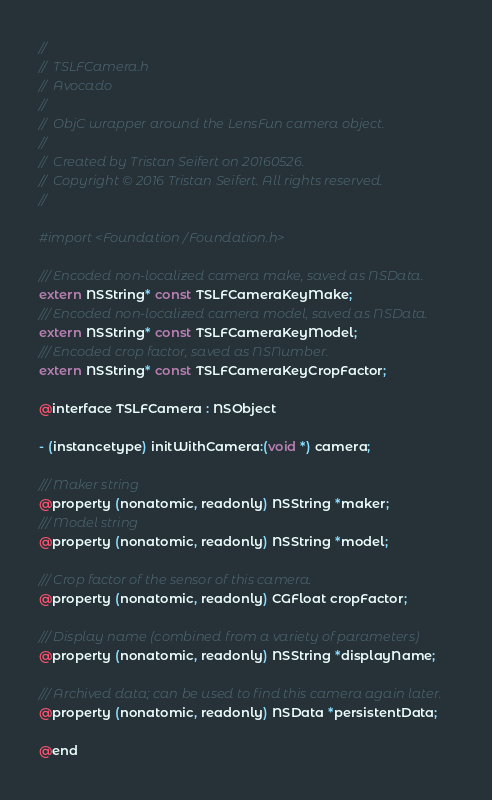Convert code to text. <code><loc_0><loc_0><loc_500><loc_500><_C_>//
//  TSLFCamera.h
//  Avocado
//
//	ObjC wrapper around the LensFun camera object.
//
//  Created by Tristan Seifert on 20160526.
//  Copyright © 2016 Tristan Seifert. All rights reserved.
//

#import <Foundation/Foundation.h>

/// Encoded non-localized camera make, saved as NSData.
extern NSString* const TSLFCameraKeyMake;
/// Encoded non-localized camera model, saved as NSData.
extern NSString* const TSLFCameraKeyModel;
/// Encoded crop factor, saved as NSNumber.
extern NSString* const TSLFCameraKeyCropFactor;

@interface TSLFCamera : NSObject

- (instancetype) initWithCamera:(void *) camera;

/// Maker string
@property (nonatomic, readonly) NSString *maker;
/// Model string
@property (nonatomic, readonly) NSString *model;

/// Crop factor of the sensor of this camera.
@property (nonatomic, readonly) CGFloat cropFactor;

/// Display name (combined from a variety of parameters)
@property (nonatomic, readonly) NSString *displayName;

/// Archived data; can be used to find this camera again later.
@property (nonatomic, readonly) NSData *persistentData;

@end
</code> 